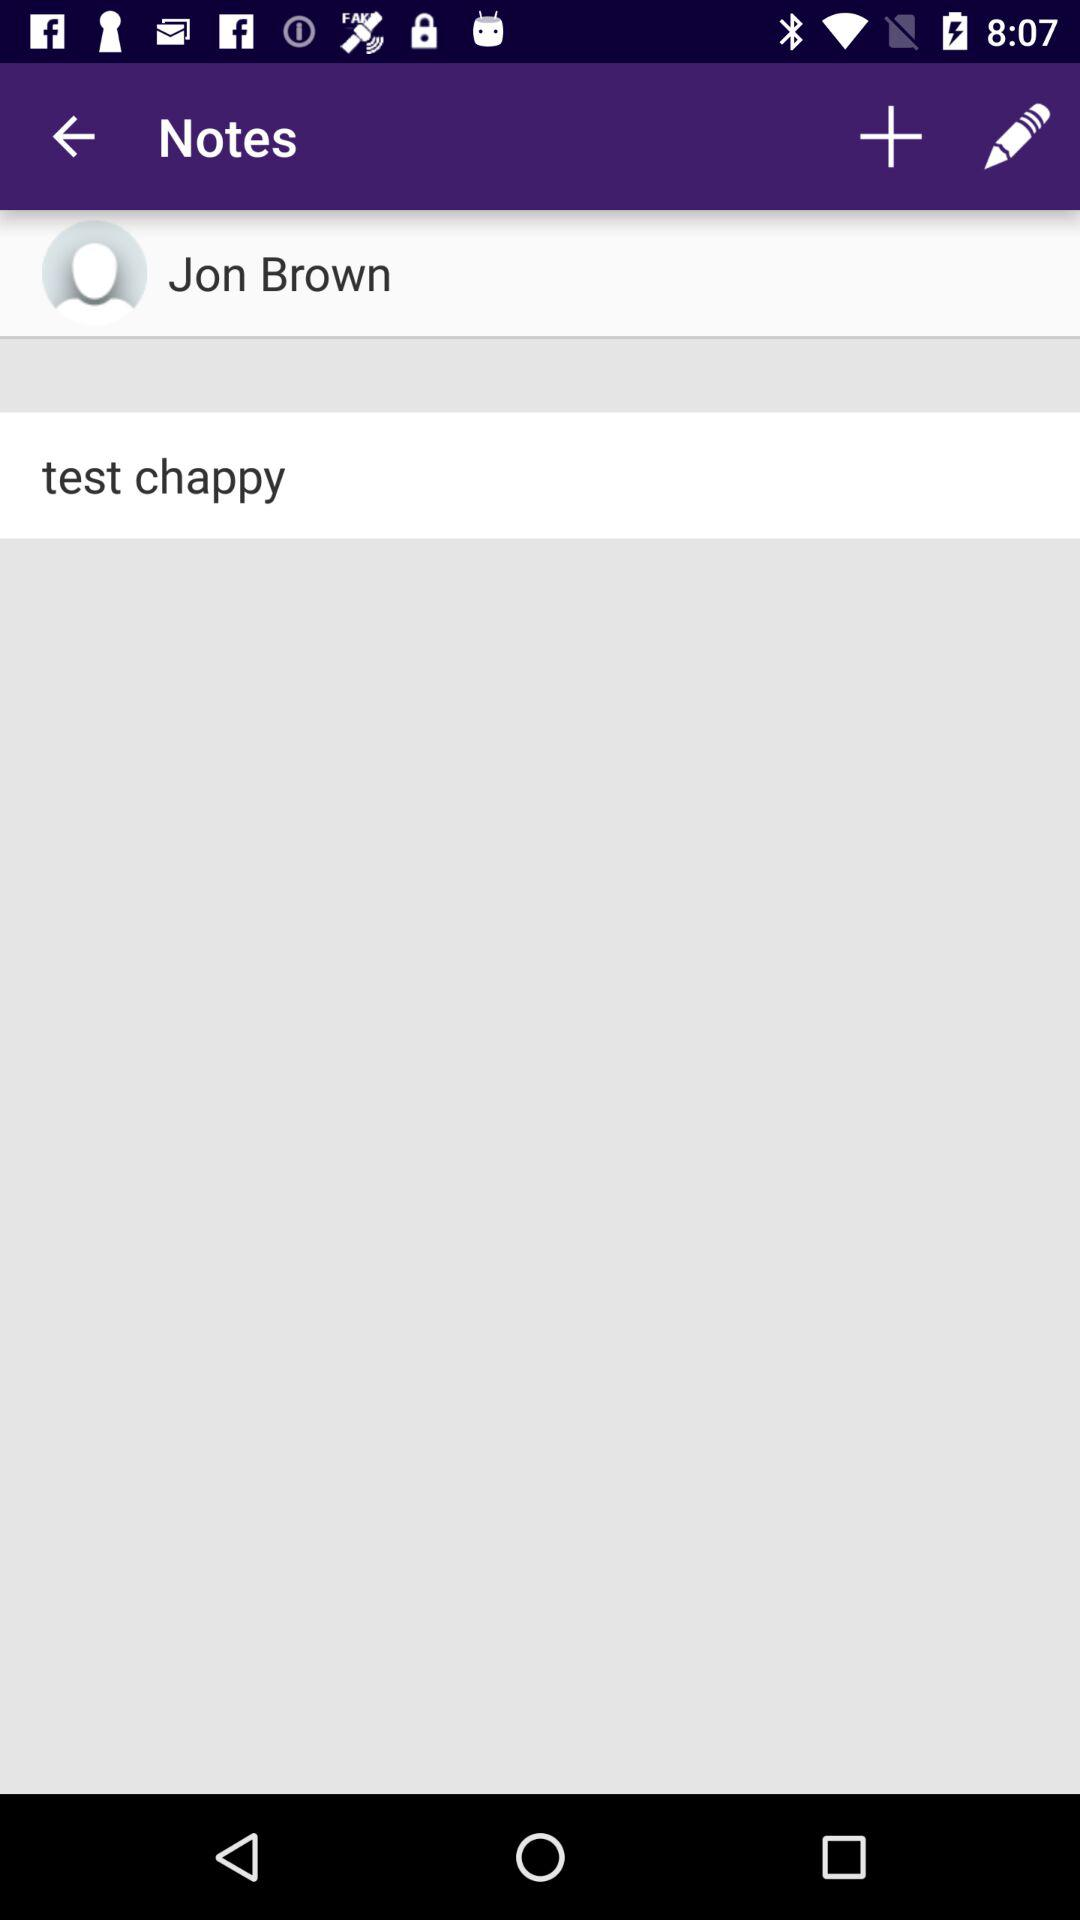What is the name of the user? The name of the user is Jon Brown. 